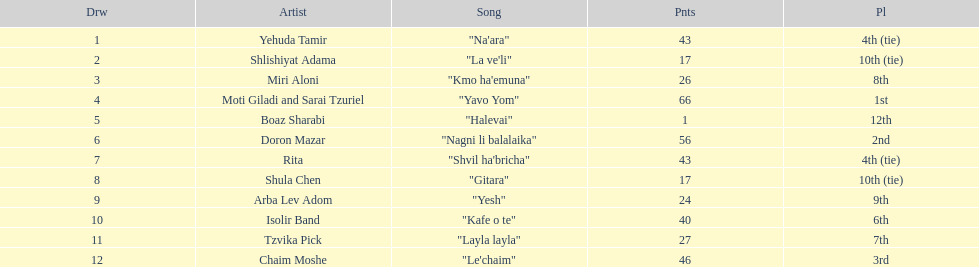How many points does the artist rita have? 43. 